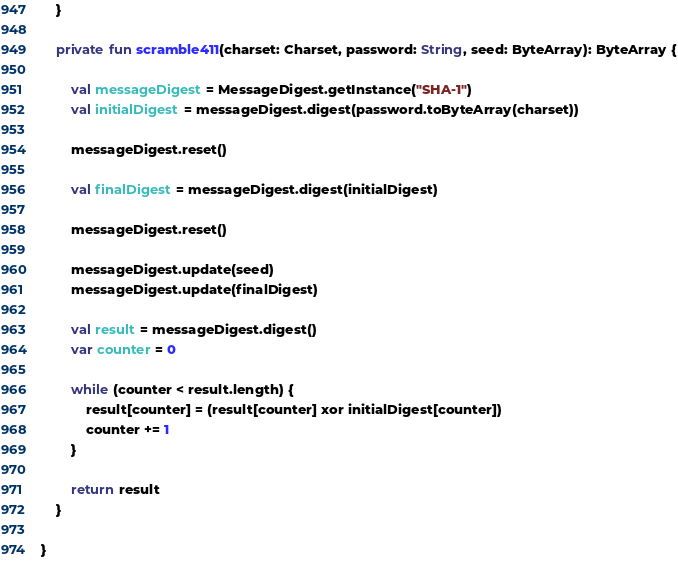<code> <loc_0><loc_0><loc_500><loc_500><_Kotlin_>    }

    private fun scramble411(charset: Charset, password: String, seed: ByteArray): ByteArray {

        val messageDigest = MessageDigest.getInstance("SHA-1")
        val initialDigest = messageDigest.digest(password.toByteArray(charset))

        messageDigest.reset()

        val finalDigest = messageDigest.digest(initialDigest)

        messageDigest.reset()

        messageDigest.update(seed)
        messageDigest.update(finalDigest)

        val result = messageDigest.digest()
        var counter = 0

        while (counter < result.length) {
            result[counter] = (result[counter] xor initialDigest[counter])
            counter += 1
        }

        return result
    }

}
</code> 